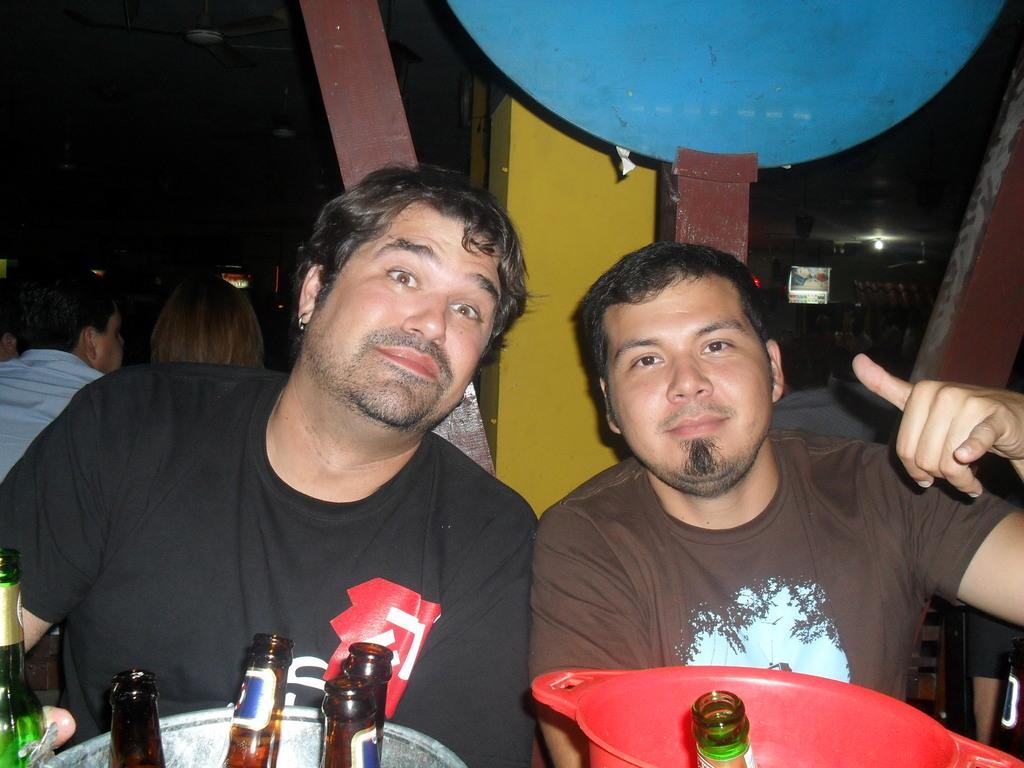Could you give a brief overview of what you see in this image? In this image, there are some wines bottles which are in brown color and green color, there are some people sitting on the chairs, in the background there is a blue color object and there are some persons sitting. 